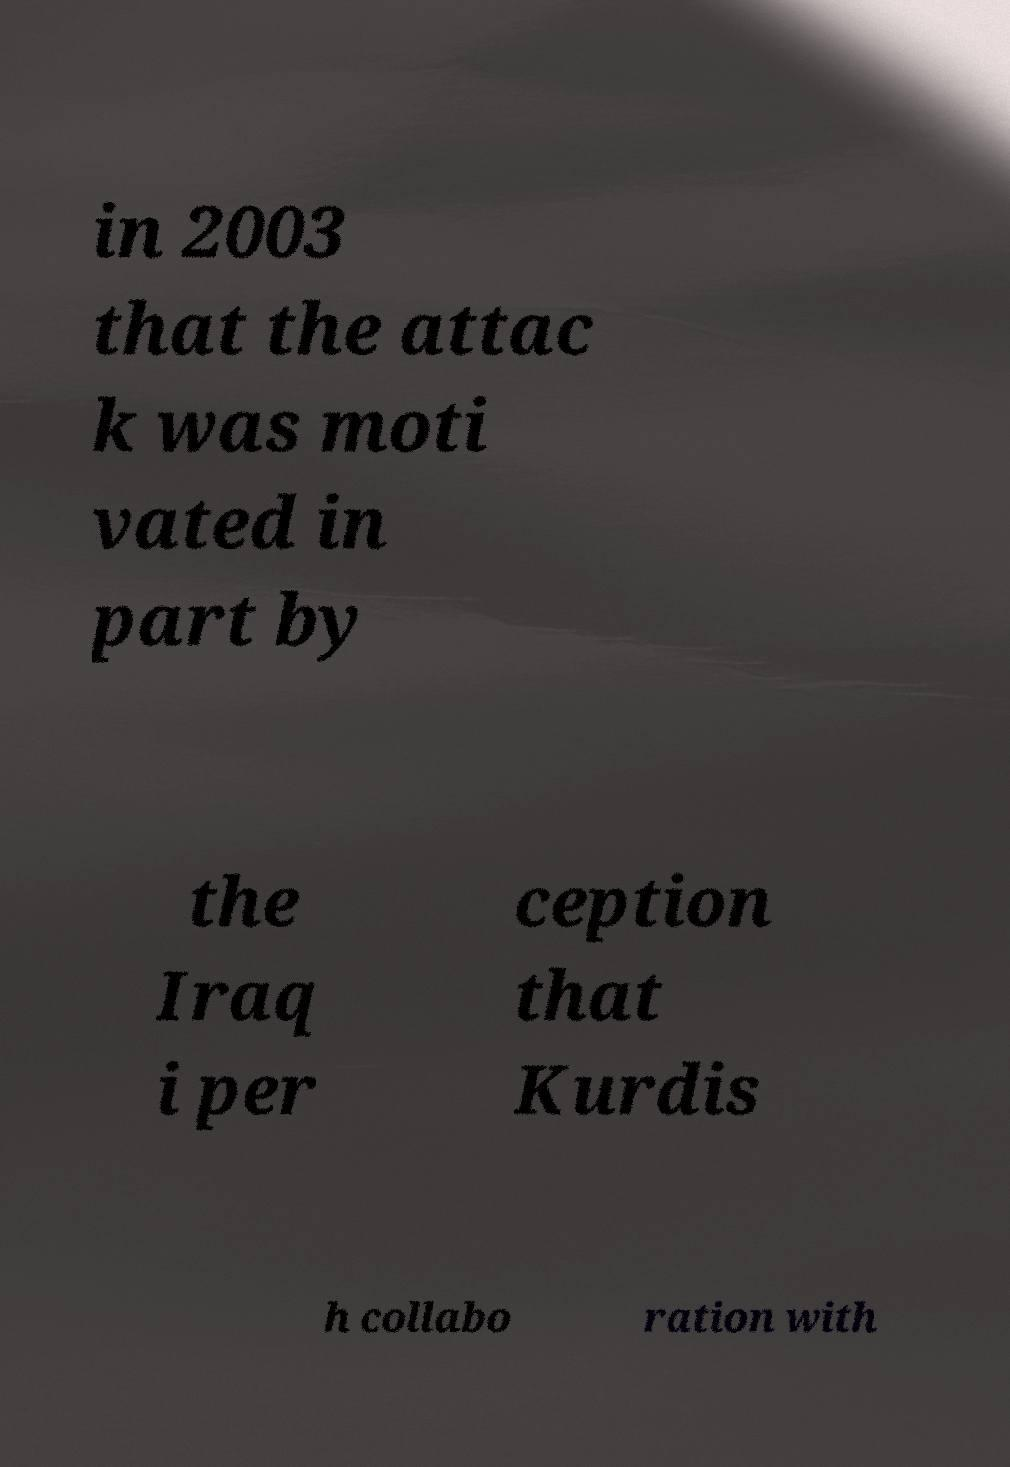Can you accurately transcribe the text from the provided image for me? in 2003 that the attac k was moti vated in part by the Iraq i per ception that Kurdis h collabo ration with 